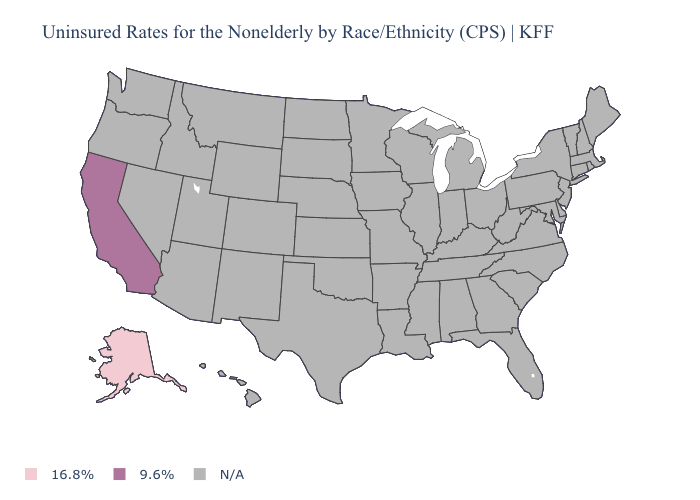What is the highest value in the USA?
Answer briefly. 9.6%. Does Alaska have the highest value in the USA?
Write a very short answer. No. What is the value of New Hampshire?
Short answer required. N/A. Does Alaska have the lowest value in the USA?
Concise answer only. Yes. What is the value of Alabama?
Concise answer only. N/A. How many symbols are there in the legend?
Keep it brief. 3. What is the lowest value in the USA?
Quick response, please. 16.8%. What is the value of Iowa?
Concise answer only. N/A. What is the value of Utah?
Write a very short answer. N/A. Name the states that have a value in the range N/A?
Be succinct. Alabama, Arizona, Arkansas, Colorado, Connecticut, Delaware, Florida, Georgia, Hawaii, Idaho, Illinois, Indiana, Iowa, Kansas, Kentucky, Louisiana, Maine, Maryland, Massachusetts, Michigan, Minnesota, Mississippi, Missouri, Montana, Nebraska, Nevada, New Hampshire, New Jersey, New Mexico, New York, North Carolina, North Dakota, Ohio, Oklahoma, Oregon, Pennsylvania, Rhode Island, South Carolina, South Dakota, Tennessee, Texas, Utah, Vermont, Virginia, Washington, West Virginia, Wisconsin, Wyoming. 